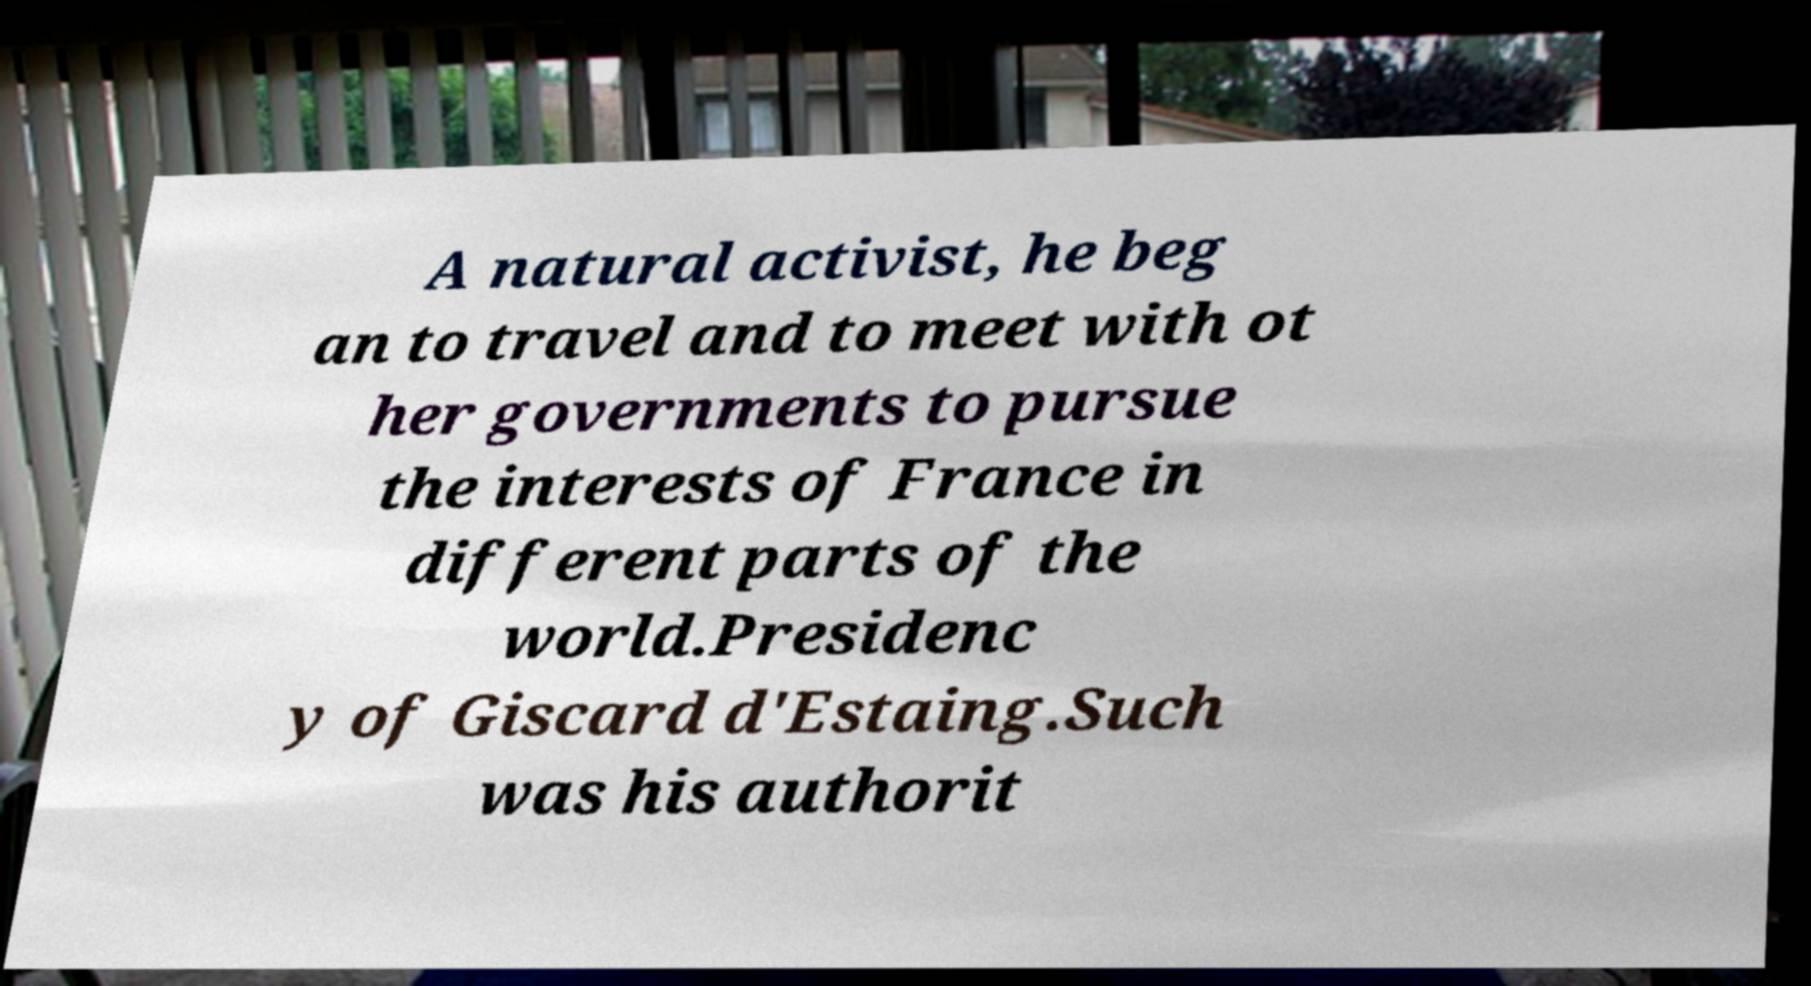For documentation purposes, I need the text within this image transcribed. Could you provide that? A natural activist, he beg an to travel and to meet with ot her governments to pursue the interests of France in different parts of the world.Presidenc y of Giscard d'Estaing.Such was his authorit 